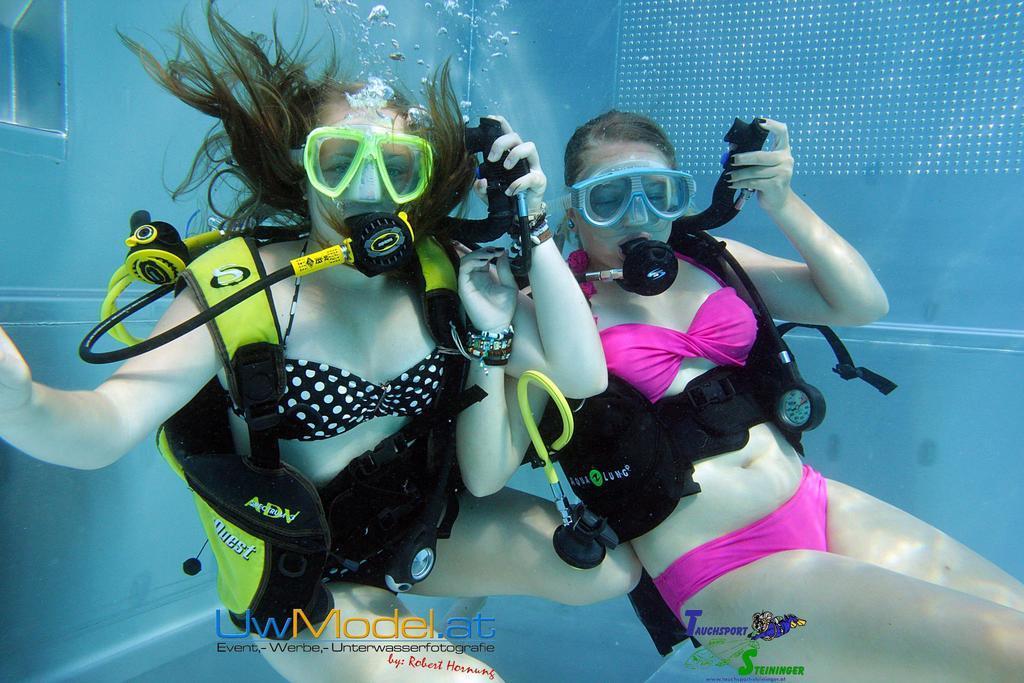How would you summarize this image in a sentence or two? In this image we can see two women in the water. Here we can see the underwater breathing equipment. 